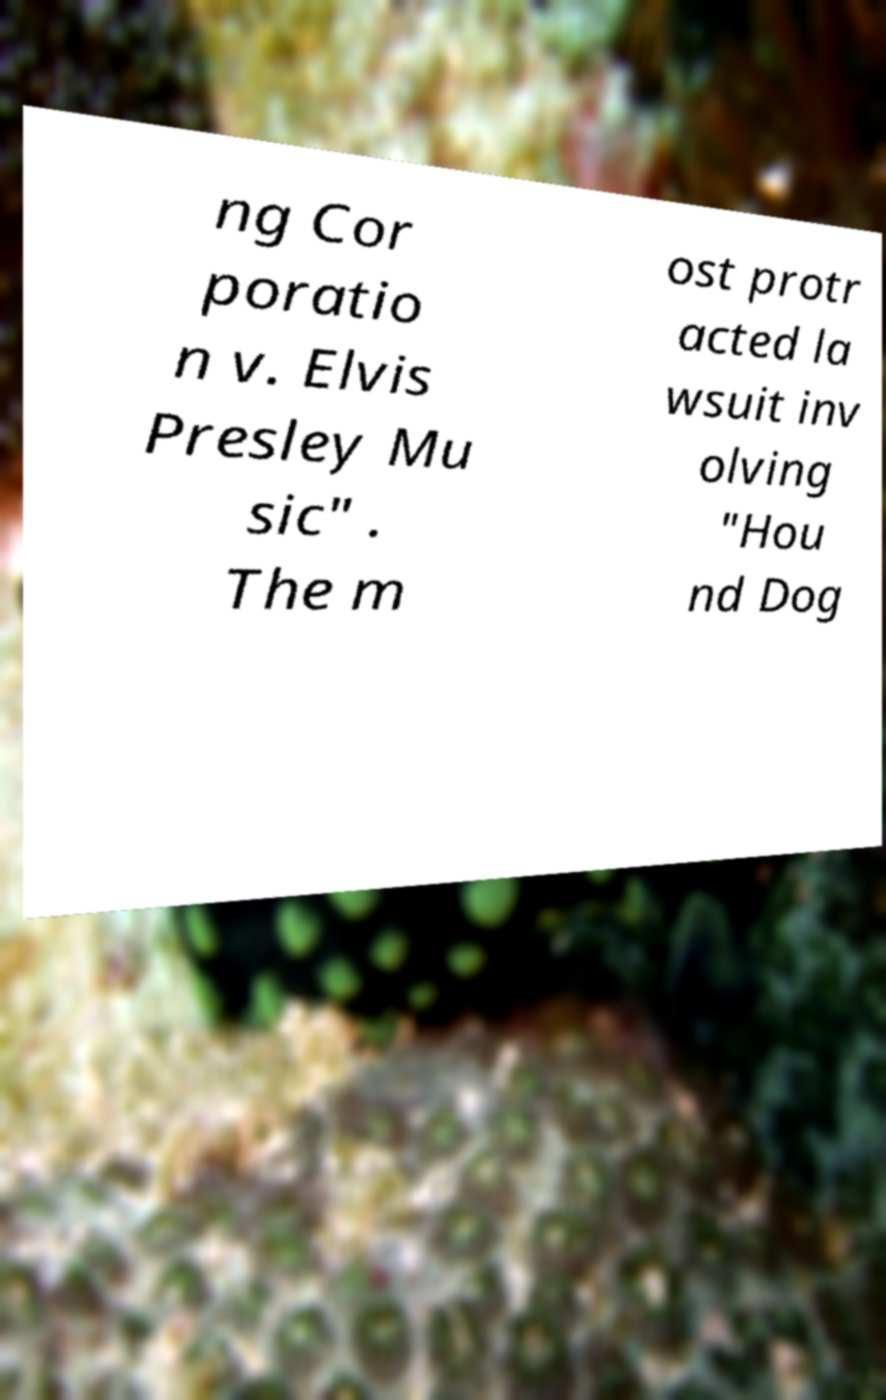Could you extract and type out the text from this image? ng Cor poratio n v. Elvis Presley Mu sic" . The m ost protr acted la wsuit inv olving "Hou nd Dog 